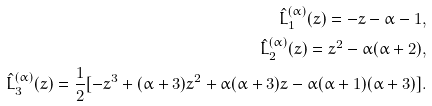<formula> <loc_0><loc_0><loc_500><loc_500>\hat { L } ^ { ( \alpha ) } _ { 1 } ( z ) = - z - \alpha - 1 , \\ \hat { L } ^ { ( \alpha ) } _ { 2 } ( z ) = z ^ { 2 } - \alpha ( \alpha + 2 ) , \\ \hat { L } ^ { ( \alpha ) } _ { 3 } ( z ) = \frac { 1 } { 2 } [ - z ^ { 3 } + ( \alpha + 3 ) z ^ { 2 } + \alpha ( \alpha + 3 ) z - \alpha ( \alpha + 1 ) ( \alpha + 3 ) ] .</formula> 